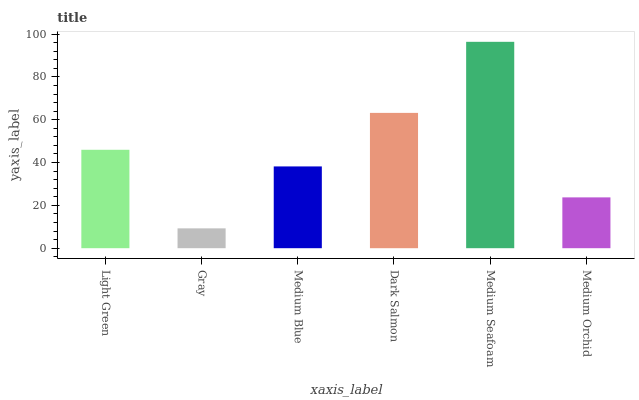Is Gray the minimum?
Answer yes or no. Yes. Is Medium Seafoam the maximum?
Answer yes or no. Yes. Is Medium Blue the minimum?
Answer yes or no. No. Is Medium Blue the maximum?
Answer yes or no. No. Is Medium Blue greater than Gray?
Answer yes or no. Yes. Is Gray less than Medium Blue?
Answer yes or no. Yes. Is Gray greater than Medium Blue?
Answer yes or no. No. Is Medium Blue less than Gray?
Answer yes or no. No. Is Light Green the high median?
Answer yes or no. Yes. Is Medium Blue the low median?
Answer yes or no. Yes. Is Medium Seafoam the high median?
Answer yes or no. No. Is Medium Orchid the low median?
Answer yes or no. No. 